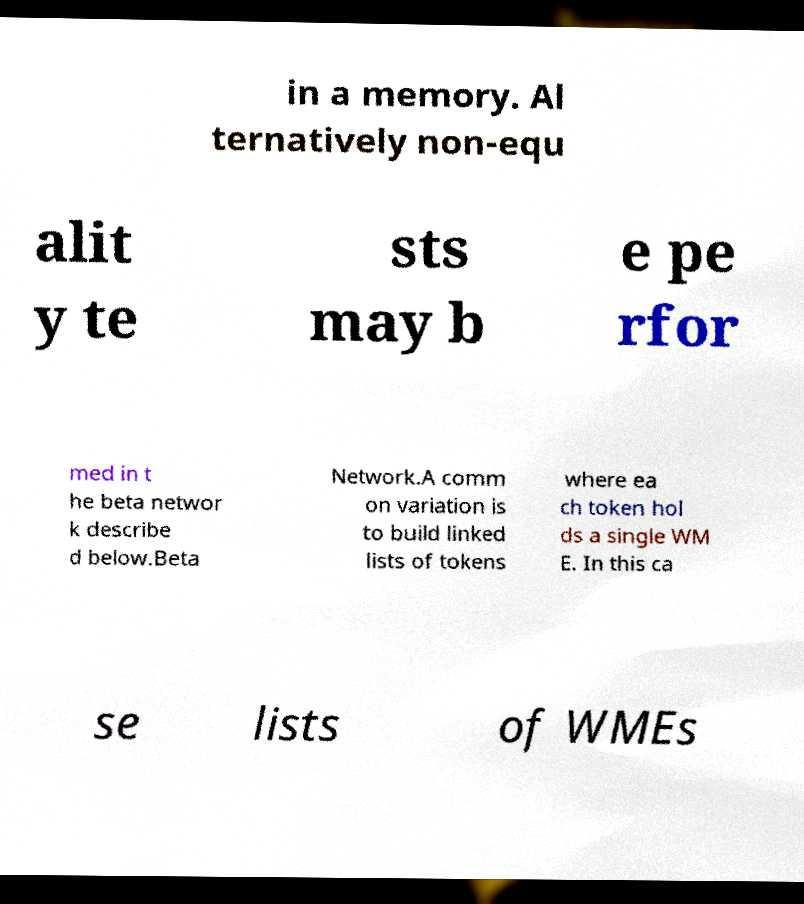Can you read and provide the text displayed in the image?This photo seems to have some interesting text. Can you extract and type it out for me? in a memory. Al ternatively non-equ alit y te sts may b e pe rfor med in t he beta networ k describe d below.Beta Network.A comm on variation is to build linked lists of tokens where ea ch token hol ds a single WM E. In this ca se lists of WMEs 